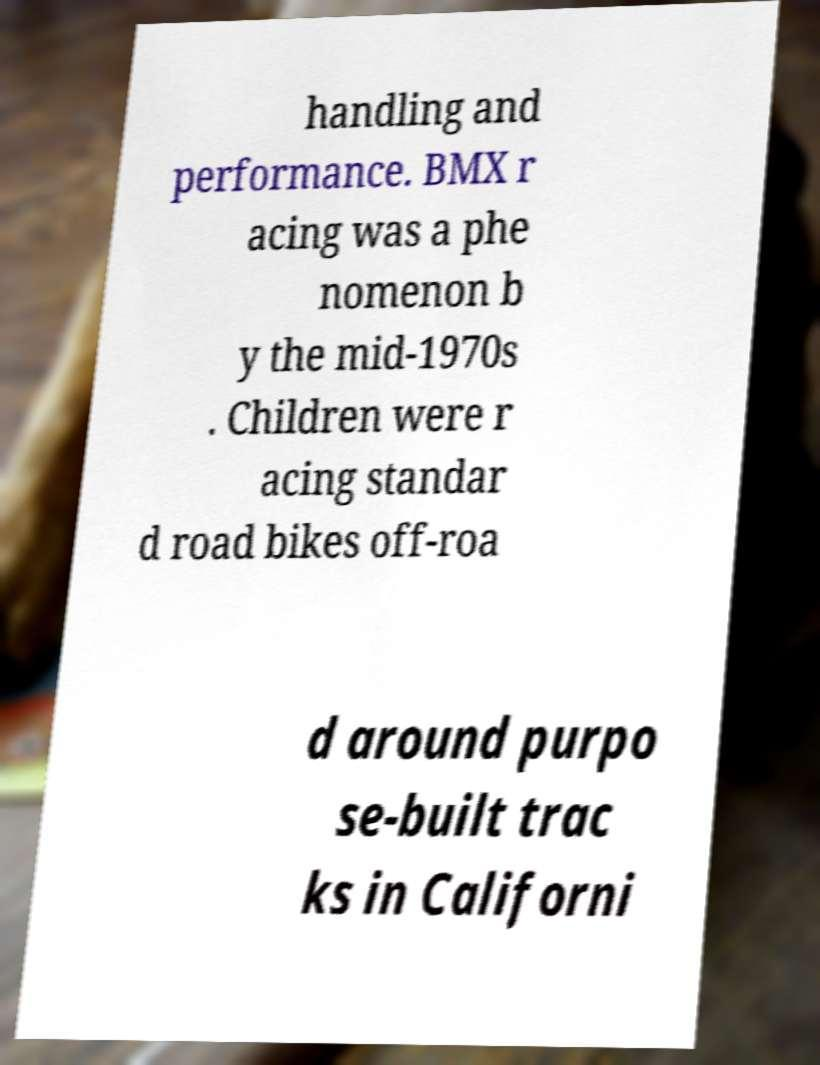For documentation purposes, I need the text within this image transcribed. Could you provide that? handling and performance. BMX r acing was a phe nomenon b y the mid-1970s . Children were r acing standar d road bikes off-roa d around purpo se-built trac ks in Californi 